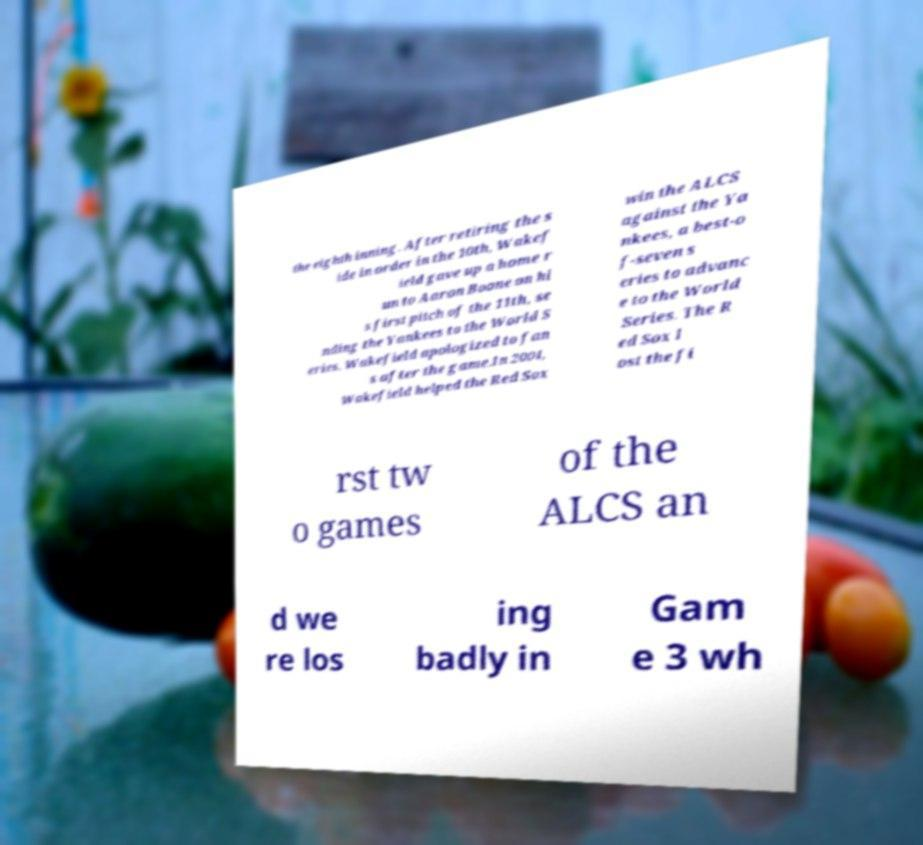Please identify and transcribe the text found in this image. the eighth inning. After retiring the s ide in order in the 10th, Wakef ield gave up a home r un to Aaron Boone on hi s first pitch of the 11th, se nding the Yankees to the World S eries. Wakefield apologized to fan s after the game.In 2004, Wakefield helped the Red Sox win the ALCS against the Ya nkees, a best-o f-seven s eries to advanc e to the World Series. The R ed Sox l ost the fi rst tw o games of the ALCS an d we re los ing badly in Gam e 3 wh 